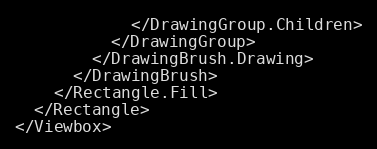<code> <loc_0><loc_0><loc_500><loc_500><_XML_>            </DrawingGroup.Children>
          </DrawingGroup>
        </DrawingBrush.Drawing>
      </DrawingBrush>
    </Rectangle.Fill>
  </Rectangle>
</Viewbox></code> 